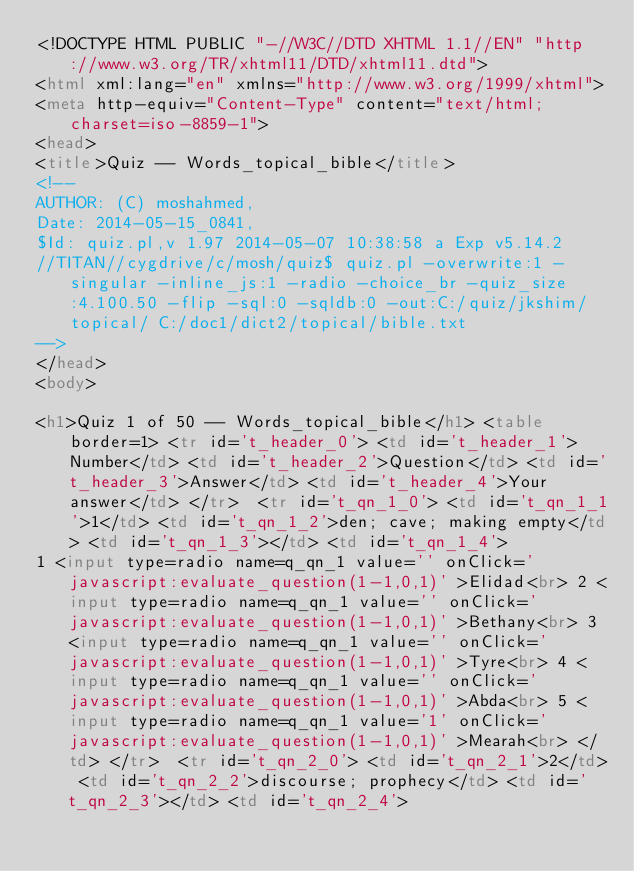Convert code to text. <code><loc_0><loc_0><loc_500><loc_500><_HTML_><!DOCTYPE HTML PUBLIC "-//W3C//DTD XHTML 1.1//EN" "http://www.w3.org/TR/xhtml11/DTD/xhtml11.dtd">
<html xml:lang="en" xmlns="http://www.w3.org/1999/xhtml">
<meta http-equiv="Content-Type" content="text/html; charset=iso-8859-1">  
<head>
<title>Quiz -- Words_topical_bible</title>
<!--
AUTHOR: (C) moshahmed,
Date: 2014-05-15_0841,
$Id: quiz.pl,v 1.97 2014-05-07 10:38:58 a Exp v5.14.2
//TITAN//cygdrive/c/mosh/quiz$ quiz.pl -overwrite:1 -singular -inline_js:1 -radio -choice_br -quiz_size:4.100.50 -flip -sql:0 -sqldb:0 -out:C:/quiz/jkshim/topical/ C:/doc1/dict2/topical/bible.txt
-->
</head>
<body>

<h1>Quiz 1 of 50 -- Words_topical_bible</h1> <table border=1> <tr id='t_header_0'> <td id='t_header_1'>Number</td> <td id='t_header_2'>Question</td> <td id='t_header_3'>Answer</td> <td id='t_header_4'>Your answer</td> </tr>  <tr id='t_qn_1_0'> <td id='t_qn_1_1'>1</td> <td id='t_qn_1_2'>den; cave; making empty</td> <td id='t_qn_1_3'></td> <td id='t_qn_1_4'>
1 <input type=radio name=q_qn_1 value='' onClick='javascript:evaluate_question(1-1,0,1)' >Elidad<br> 2 <input type=radio name=q_qn_1 value='' onClick='javascript:evaluate_question(1-1,0,1)' >Bethany<br> 3 <input type=radio name=q_qn_1 value='' onClick='javascript:evaluate_question(1-1,0,1)' >Tyre<br> 4 <input type=radio name=q_qn_1 value='' onClick='javascript:evaluate_question(1-1,0,1)' >Abda<br> 5 <input type=radio name=q_qn_1 value='1' onClick='javascript:evaluate_question(1-1,0,1)' >Mearah<br> </td> </tr>  <tr id='t_qn_2_0'> <td id='t_qn_2_1'>2</td> <td id='t_qn_2_2'>discourse; prophecy</td> <td id='t_qn_2_3'></td> <td id='t_qn_2_4'></code> 